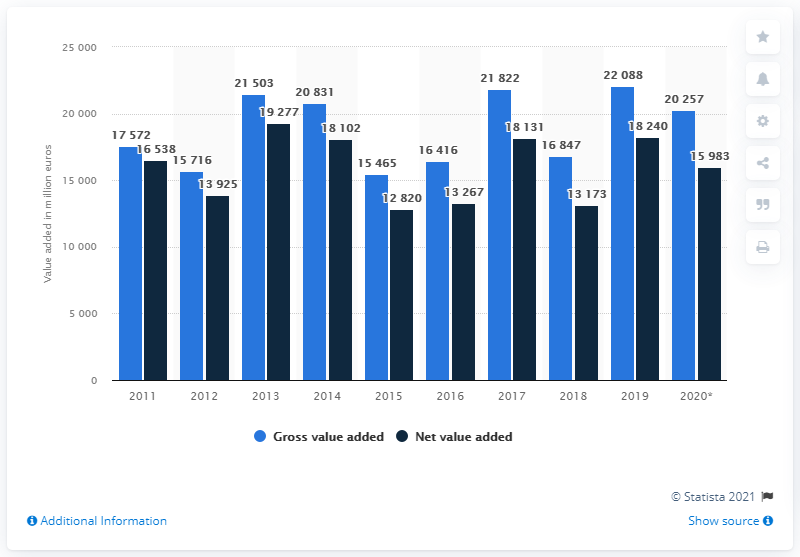Highlight a few significant elements in this photo. In 2020, the gross value added of agriculture in Germany was 202,571 million euros. 